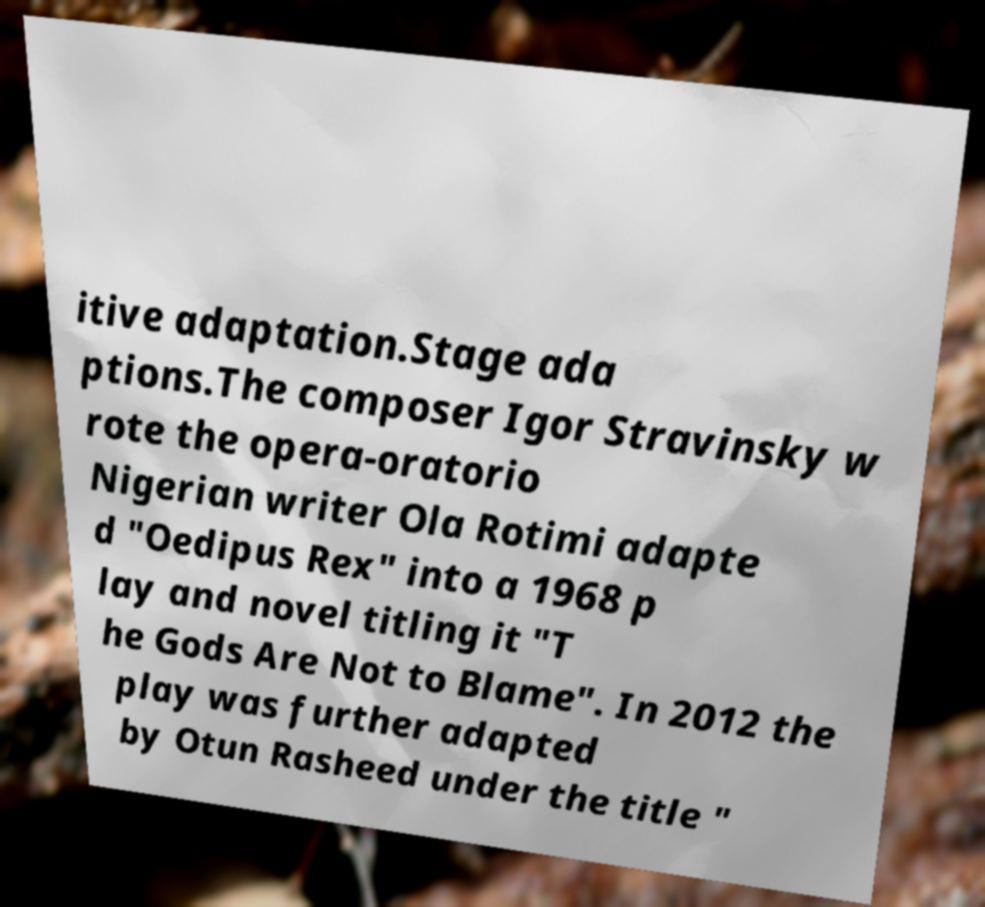For documentation purposes, I need the text within this image transcribed. Could you provide that? itive adaptation.Stage ada ptions.The composer Igor Stravinsky w rote the opera-oratorio Nigerian writer Ola Rotimi adapte d "Oedipus Rex" into a 1968 p lay and novel titling it "T he Gods Are Not to Blame". In 2012 the play was further adapted by Otun Rasheed under the title " 